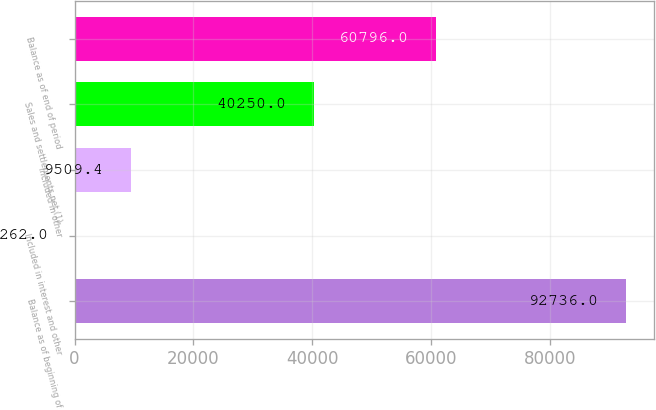Convert chart to OTSL. <chart><loc_0><loc_0><loc_500><loc_500><bar_chart><fcel>Balance as of beginning of<fcel>Included in interest and other<fcel>Included in other<fcel>Sales and settlements net (1)<fcel>Balance as of end of period<nl><fcel>92736<fcel>262<fcel>9509.4<fcel>40250<fcel>60796<nl></chart> 